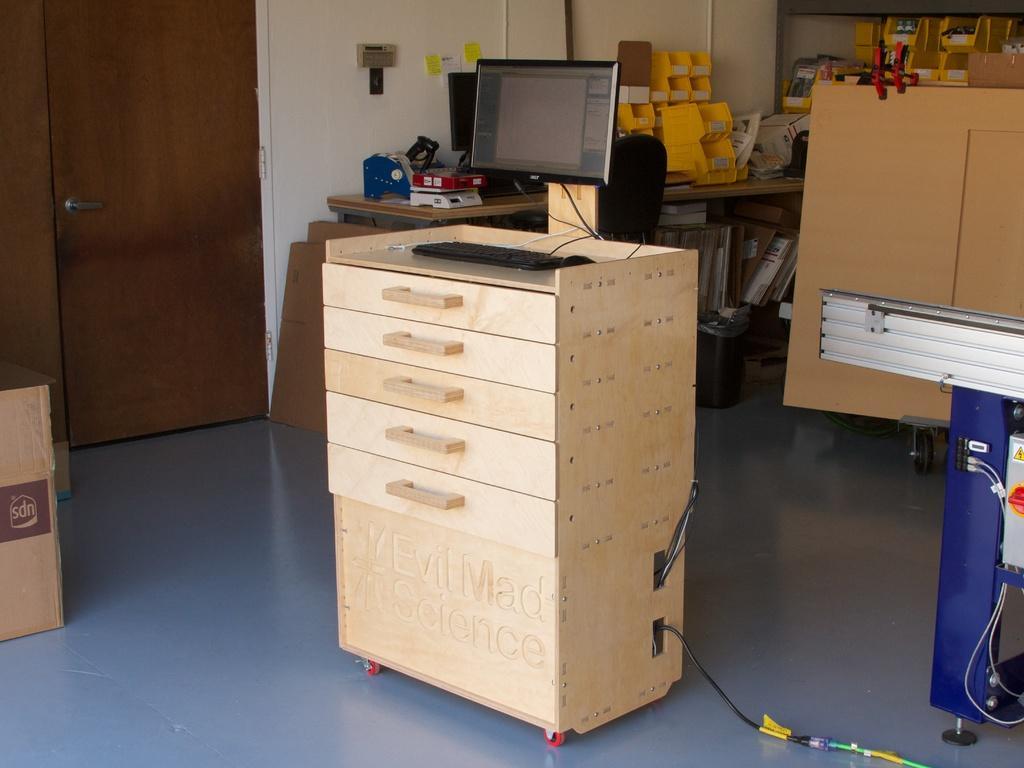Describe this image in one or two sentences. In this picture there is a wooden desk in the center of the image, on which there is a keyboard and a monitor, there is a door on the left side of the image and there are boxes in the top right side of the image. 